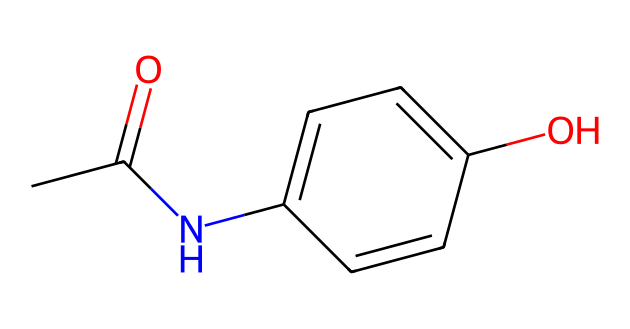How many carbon atoms are in acetaminophen? The SMILES representation shows multiple 'C' characters which represent carbon atoms. Counting them gives us a total of 8 carbon atoms in the structure.
Answer: 8 What functional groups are present in acetaminophen? The structure has a hydroxyl group (-OH) and an amide group (the nitrogen bonded to the carbon). The hydroxyl group indicates it is phenolic, and the amide indicates the presence of an amine.
Answer: hydroxyl and amide What is the molecular formula of acetaminophen? From the SMILES, we can count the atoms: 8 carbons, 9 hydrogens, 1 nitrogen, and 1 oxygen. Combining these gives us the molecular formula C8H9NO2.
Answer: C8H9NO2 How many rings are present in the chemical structure of acetaminophen? The structure contains one aromatic ring (the benzene-like ring shown by “C1=CC=C(C=C1)”) where the 'C1' indicates the start and end of a ring structure.
Answer: 1 What type of compound is acetaminophen categorized as? Acetaminophen is commonly known as a pain reliever or analgesic. Given its structure, it specifically falls into the category of non-opioid analgesics.
Answer: non-opioid analgesic What structural element allows acetaminophen to reduce pain? The presence of the para-hydroxy group (-OH) and the amide structure help with pain-relief properties as they affect the inhibition of cyclooxygenase enzymes in the body.
Answer: para-hydroxy group and amide structure Does acetaminophen contain any nitrogen atoms? The SMILES structure clearly identifies a nitrogen atom represented as 'N' which confirms its presence in acetaminophen.
Answer: Yes 